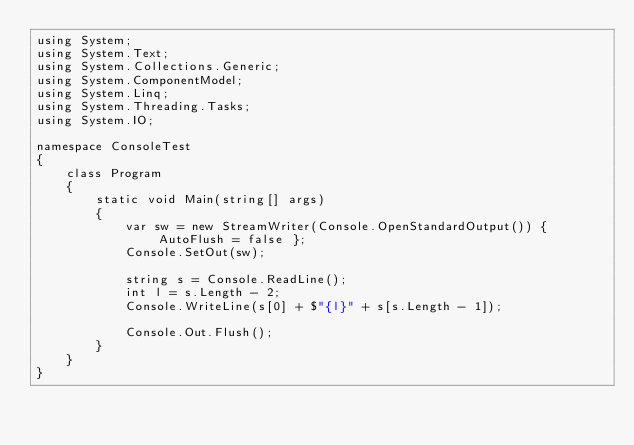<code> <loc_0><loc_0><loc_500><loc_500><_C#_>using System;
using System.Text;
using System.Collections.Generic;
using System.ComponentModel;
using System.Linq;
using System.Threading.Tasks;
using System.IO;

namespace ConsoleTest
{
    class Program
    {
        static void Main(string[] args)
        {
            var sw = new StreamWriter(Console.OpenStandardOutput()) { AutoFlush = false };
            Console.SetOut(sw);

            string s = Console.ReadLine();
            int l = s.Length - 2;
            Console.WriteLine(s[0] + $"{l}" + s[s.Length - 1]);

            Console.Out.Flush();
        }
    }
}
</code> 